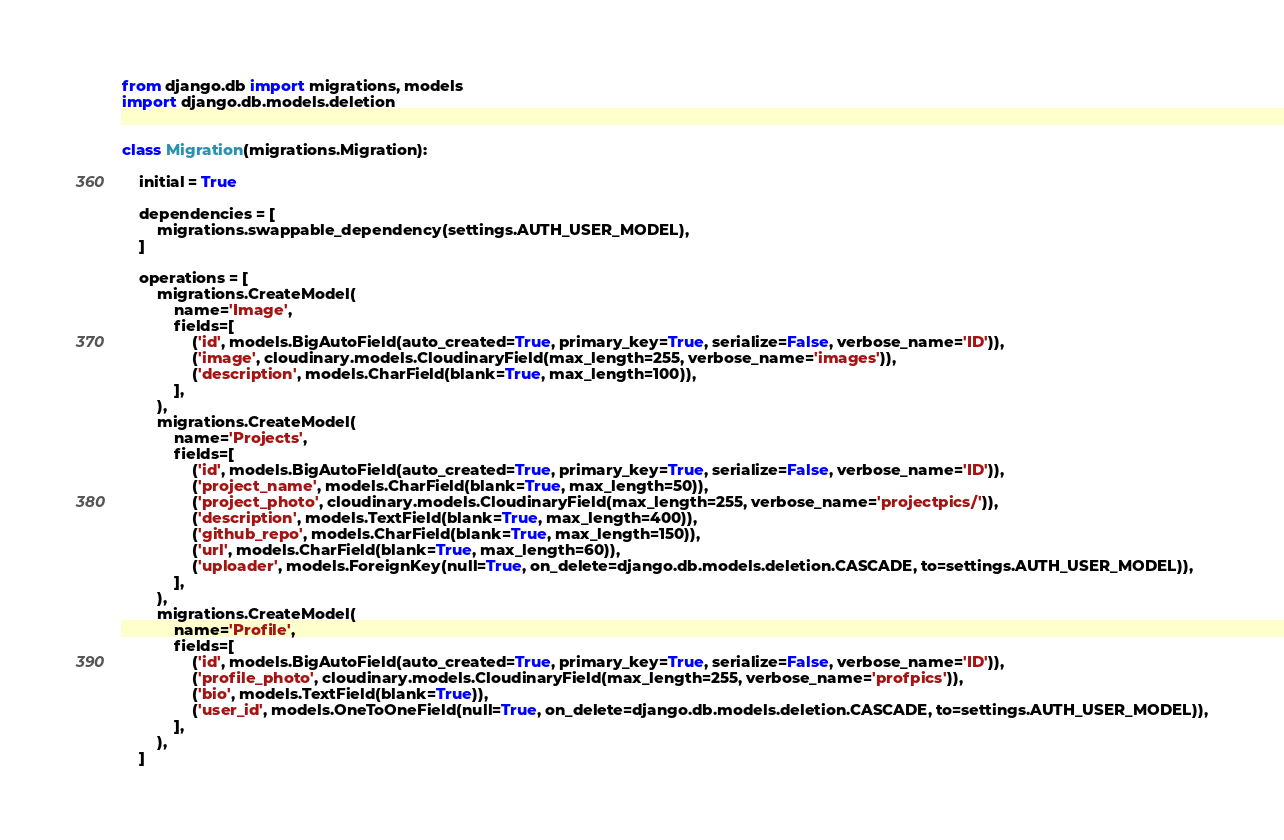<code> <loc_0><loc_0><loc_500><loc_500><_Python_>from django.db import migrations, models
import django.db.models.deletion


class Migration(migrations.Migration):

    initial = True

    dependencies = [
        migrations.swappable_dependency(settings.AUTH_USER_MODEL),
    ]

    operations = [
        migrations.CreateModel(
            name='Image',
            fields=[
                ('id', models.BigAutoField(auto_created=True, primary_key=True, serialize=False, verbose_name='ID')),
                ('image', cloudinary.models.CloudinaryField(max_length=255, verbose_name='images')),
                ('description', models.CharField(blank=True, max_length=100)),
            ],
        ),
        migrations.CreateModel(
            name='Projects',
            fields=[
                ('id', models.BigAutoField(auto_created=True, primary_key=True, serialize=False, verbose_name='ID')),
                ('project_name', models.CharField(blank=True, max_length=50)),
                ('project_photo', cloudinary.models.CloudinaryField(max_length=255, verbose_name='projectpics/')),
                ('description', models.TextField(blank=True, max_length=400)),
                ('github_repo', models.CharField(blank=True, max_length=150)),
                ('url', models.CharField(blank=True, max_length=60)),
                ('uploader', models.ForeignKey(null=True, on_delete=django.db.models.deletion.CASCADE, to=settings.AUTH_USER_MODEL)),
            ],
        ),
        migrations.CreateModel(
            name='Profile',
            fields=[
                ('id', models.BigAutoField(auto_created=True, primary_key=True, serialize=False, verbose_name='ID')),
                ('profile_photo', cloudinary.models.CloudinaryField(max_length=255, verbose_name='profpics')),
                ('bio', models.TextField(blank=True)),
                ('user_id', models.OneToOneField(null=True, on_delete=django.db.models.deletion.CASCADE, to=settings.AUTH_USER_MODEL)),
            ],
        ),
    ]
</code> 